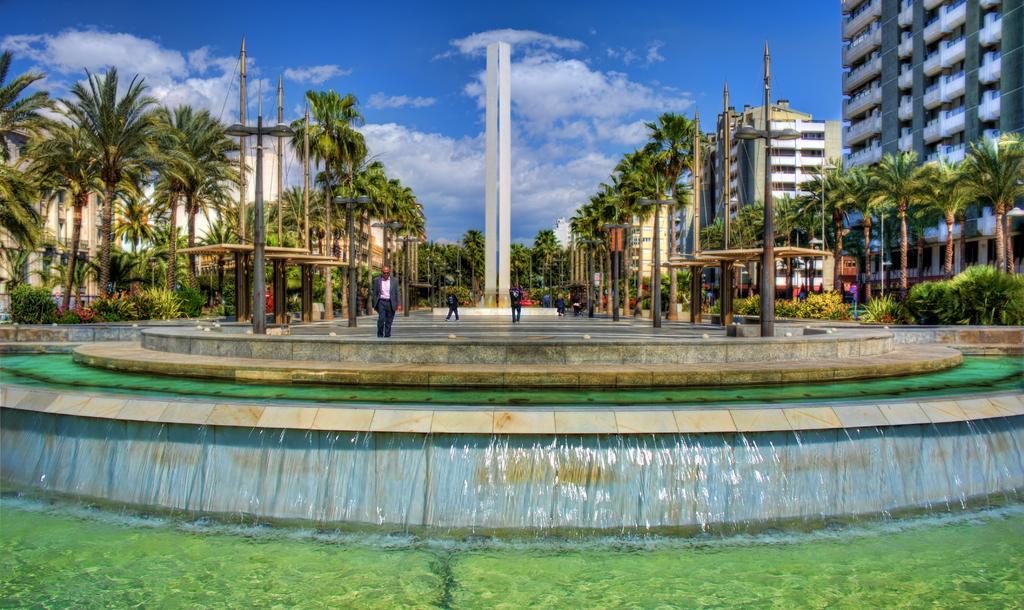In one or two sentences, can you explain what this image depicts? In this picture we can see some grass on the ground. There is a waterfall. We can see a few people on the path. There are some poles, trees and few buildings in the background. Sky is blue in color and cloudy. 